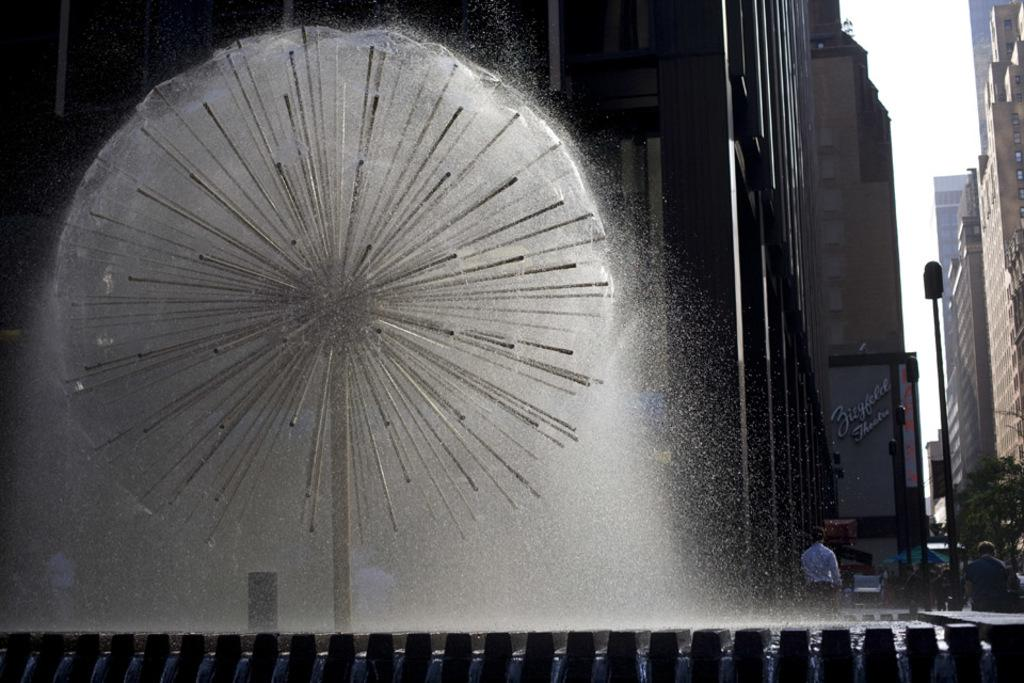What is the main subject in the image? There is a water fountain in the image. What can be seen in the background of the image? There are people and buildings visible in the background. What is located on the right side of the image? There is a tree and poles on the right side of the image. What part of the natural environment is visible in the image? The sky is visible on the right side of the image. What is the purpose of the face visible in the image? There is no face visible in the image; the main subject is a water fountain. 